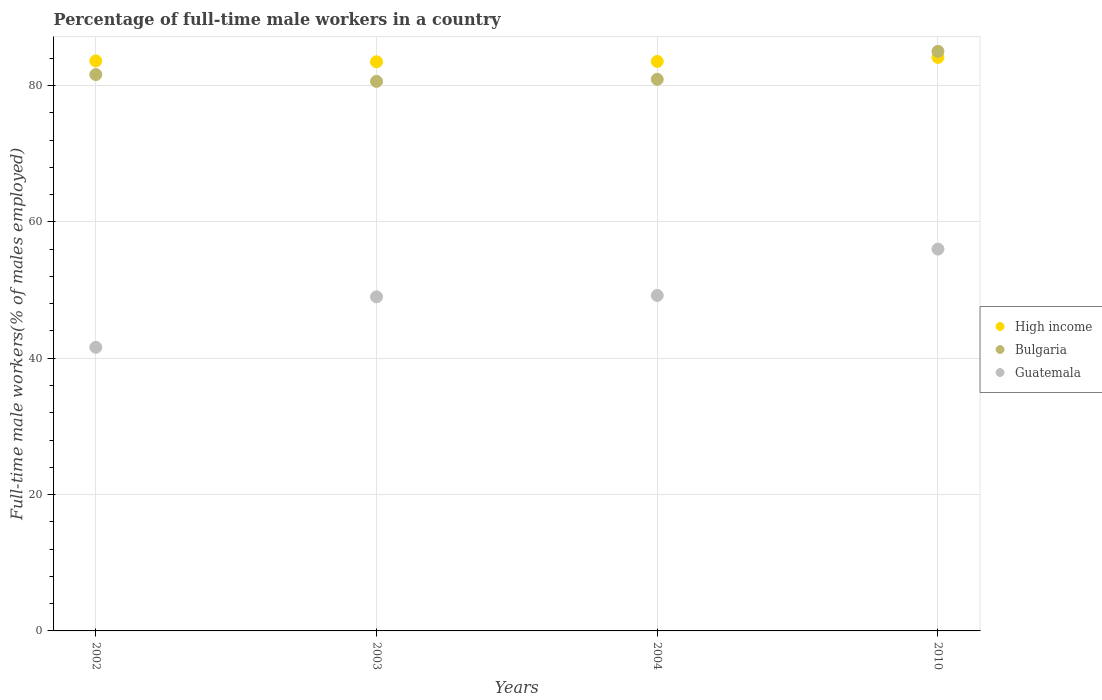Is the number of dotlines equal to the number of legend labels?
Provide a succinct answer. Yes. What is the percentage of full-time male workers in High income in 2002?
Give a very brief answer. 83.6. Across all years, what is the maximum percentage of full-time male workers in Bulgaria?
Give a very brief answer. 85. Across all years, what is the minimum percentage of full-time male workers in Guatemala?
Make the answer very short. 41.6. In which year was the percentage of full-time male workers in High income minimum?
Your answer should be very brief. 2003. What is the total percentage of full-time male workers in Guatemala in the graph?
Provide a succinct answer. 195.8. What is the difference between the percentage of full-time male workers in High income in 2002 and that in 2004?
Provide a succinct answer. 0.07. What is the difference between the percentage of full-time male workers in Bulgaria in 2003 and the percentage of full-time male workers in High income in 2010?
Make the answer very short. -3.51. What is the average percentage of full-time male workers in Bulgaria per year?
Make the answer very short. 82.02. In the year 2004, what is the difference between the percentage of full-time male workers in High income and percentage of full-time male workers in Guatemala?
Ensure brevity in your answer.  34.33. In how many years, is the percentage of full-time male workers in Guatemala greater than 68 %?
Provide a succinct answer. 0. What is the ratio of the percentage of full-time male workers in Bulgaria in 2004 to that in 2010?
Offer a terse response. 0.95. Is the percentage of full-time male workers in Guatemala in 2002 less than that in 2010?
Your response must be concise. Yes. What is the difference between the highest and the second highest percentage of full-time male workers in Guatemala?
Your response must be concise. 6.8. What is the difference between the highest and the lowest percentage of full-time male workers in High income?
Give a very brief answer. 0.64. In how many years, is the percentage of full-time male workers in Guatemala greater than the average percentage of full-time male workers in Guatemala taken over all years?
Provide a succinct answer. 3. Is the sum of the percentage of full-time male workers in High income in 2002 and 2004 greater than the maximum percentage of full-time male workers in Bulgaria across all years?
Your response must be concise. Yes. Is the percentage of full-time male workers in Bulgaria strictly greater than the percentage of full-time male workers in Guatemala over the years?
Your answer should be very brief. Yes. Is the percentage of full-time male workers in High income strictly less than the percentage of full-time male workers in Guatemala over the years?
Make the answer very short. No. How many years are there in the graph?
Make the answer very short. 4. What is the difference between two consecutive major ticks on the Y-axis?
Your answer should be very brief. 20. Are the values on the major ticks of Y-axis written in scientific E-notation?
Your response must be concise. No. Does the graph contain any zero values?
Ensure brevity in your answer.  No. Where does the legend appear in the graph?
Make the answer very short. Center right. How many legend labels are there?
Make the answer very short. 3. How are the legend labels stacked?
Offer a terse response. Vertical. What is the title of the graph?
Your response must be concise. Percentage of full-time male workers in a country. Does "Egypt, Arab Rep." appear as one of the legend labels in the graph?
Provide a succinct answer. No. What is the label or title of the X-axis?
Your answer should be compact. Years. What is the label or title of the Y-axis?
Your response must be concise. Full-time male workers(% of males employed). What is the Full-time male workers(% of males employed) of High income in 2002?
Your answer should be compact. 83.6. What is the Full-time male workers(% of males employed) of Bulgaria in 2002?
Offer a terse response. 81.6. What is the Full-time male workers(% of males employed) in Guatemala in 2002?
Your answer should be very brief. 41.6. What is the Full-time male workers(% of males employed) in High income in 2003?
Ensure brevity in your answer.  83.47. What is the Full-time male workers(% of males employed) of Bulgaria in 2003?
Provide a succinct answer. 80.6. What is the Full-time male workers(% of males employed) of Guatemala in 2003?
Offer a very short reply. 49. What is the Full-time male workers(% of males employed) of High income in 2004?
Ensure brevity in your answer.  83.53. What is the Full-time male workers(% of males employed) in Bulgaria in 2004?
Provide a succinct answer. 80.9. What is the Full-time male workers(% of males employed) in Guatemala in 2004?
Offer a very short reply. 49.2. What is the Full-time male workers(% of males employed) of High income in 2010?
Keep it short and to the point. 84.11. What is the Full-time male workers(% of males employed) in Guatemala in 2010?
Your answer should be compact. 56. Across all years, what is the maximum Full-time male workers(% of males employed) of High income?
Offer a terse response. 84.11. Across all years, what is the minimum Full-time male workers(% of males employed) of High income?
Your answer should be very brief. 83.47. Across all years, what is the minimum Full-time male workers(% of males employed) of Bulgaria?
Make the answer very short. 80.6. Across all years, what is the minimum Full-time male workers(% of males employed) in Guatemala?
Provide a succinct answer. 41.6. What is the total Full-time male workers(% of males employed) of High income in the graph?
Keep it short and to the point. 334.71. What is the total Full-time male workers(% of males employed) of Bulgaria in the graph?
Your response must be concise. 328.1. What is the total Full-time male workers(% of males employed) in Guatemala in the graph?
Keep it short and to the point. 195.8. What is the difference between the Full-time male workers(% of males employed) in High income in 2002 and that in 2003?
Keep it short and to the point. 0.13. What is the difference between the Full-time male workers(% of males employed) in Bulgaria in 2002 and that in 2003?
Provide a succinct answer. 1. What is the difference between the Full-time male workers(% of males employed) of Guatemala in 2002 and that in 2003?
Provide a succinct answer. -7.4. What is the difference between the Full-time male workers(% of males employed) of High income in 2002 and that in 2004?
Your response must be concise. 0.07. What is the difference between the Full-time male workers(% of males employed) in Bulgaria in 2002 and that in 2004?
Provide a succinct answer. 0.7. What is the difference between the Full-time male workers(% of males employed) of Guatemala in 2002 and that in 2004?
Your answer should be very brief. -7.6. What is the difference between the Full-time male workers(% of males employed) of High income in 2002 and that in 2010?
Give a very brief answer. -0.51. What is the difference between the Full-time male workers(% of males employed) of Bulgaria in 2002 and that in 2010?
Keep it short and to the point. -3.4. What is the difference between the Full-time male workers(% of males employed) of Guatemala in 2002 and that in 2010?
Your answer should be compact. -14.4. What is the difference between the Full-time male workers(% of males employed) in High income in 2003 and that in 2004?
Provide a short and direct response. -0.06. What is the difference between the Full-time male workers(% of males employed) in High income in 2003 and that in 2010?
Your response must be concise. -0.64. What is the difference between the Full-time male workers(% of males employed) in High income in 2004 and that in 2010?
Your answer should be very brief. -0.58. What is the difference between the Full-time male workers(% of males employed) in Bulgaria in 2004 and that in 2010?
Offer a very short reply. -4.1. What is the difference between the Full-time male workers(% of males employed) of Guatemala in 2004 and that in 2010?
Your answer should be very brief. -6.8. What is the difference between the Full-time male workers(% of males employed) of High income in 2002 and the Full-time male workers(% of males employed) of Bulgaria in 2003?
Give a very brief answer. 3. What is the difference between the Full-time male workers(% of males employed) of High income in 2002 and the Full-time male workers(% of males employed) of Guatemala in 2003?
Your response must be concise. 34.6. What is the difference between the Full-time male workers(% of males employed) in Bulgaria in 2002 and the Full-time male workers(% of males employed) in Guatemala in 2003?
Keep it short and to the point. 32.6. What is the difference between the Full-time male workers(% of males employed) of High income in 2002 and the Full-time male workers(% of males employed) of Bulgaria in 2004?
Keep it short and to the point. 2.7. What is the difference between the Full-time male workers(% of males employed) in High income in 2002 and the Full-time male workers(% of males employed) in Guatemala in 2004?
Your response must be concise. 34.4. What is the difference between the Full-time male workers(% of males employed) in Bulgaria in 2002 and the Full-time male workers(% of males employed) in Guatemala in 2004?
Ensure brevity in your answer.  32.4. What is the difference between the Full-time male workers(% of males employed) of High income in 2002 and the Full-time male workers(% of males employed) of Bulgaria in 2010?
Your answer should be compact. -1.4. What is the difference between the Full-time male workers(% of males employed) in High income in 2002 and the Full-time male workers(% of males employed) in Guatemala in 2010?
Ensure brevity in your answer.  27.6. What is the difference between the Full-time male workers(% of males employed) in Bulgaria in 2002 and the Full-time male workers(% of males employed) in Guatemala in 2010?
Keep it short and to the point. 25.6. What is the difference between the Full-time male workers(% of males employed) in High income in 2003 and the Full-time male workers(% of males employed) in Bulgaria in 2004?
Provide a short and direct response. 2.57. What is the difference between the Full-time male workers(% of males employed) in High income in 2003 and the Full-time male workers(% of males employed) in Guatemala in 2004?
Make the answer very short. 34.27. What is the difference between the Full-time male workers(% of males employed) of Bulgaria in 2003 and the Full-time male workers(% of males employed) of Guatemala in 2004?
Offer a terse response. 31.4. What is the difference between the Full-time male workers(% of males employed) in High income in 2003 and the Full-time male workers(% of males employed) in Bulgaria in 2010?
Your answer should be very brief. -1.53. What is the difference between the Full-time male workers(% of males employed) in High income in 2003 and the Full-time male workers(% of males employed) in Guatemala in 2010?
Your answer should be very brief. 27.47. What is the difference between the Full-time male workers(% of males employed) of Bulgaria in 2003 and the Full-time male workers(% of males employed) of Guatemala in 2010?
Offer a very short reply. 24.6. What is the difference between the Full-time male workers(% of males employed) of High income in 2004 and the Full-time male workers(% of males employed) of Bulgaria in 2010?
Give a very brief answer. -1.47. What is the difference between the Full-time male workers(% of males employed) of High income in 2004 and the Full-time male workers(% of males employed) of Guatemala in 2010?
Your answer should be compact. 27.53. What is the difference between the Full-time male workers(% of males employed) in Bulgaria in 2004 and the Full-time male workers(% of males employed) in Guatemala in 2010?
Offer a terse response. 24.9. What is the average Full-time male workers(% of males employed) of High income per year?
Offer a very short reply. 83.68. What is the average Full-time male workers(% of males employed) in Bulgaria per year?
Keep it short and to the point. 82.03. What is the average Full-time male workers(% of males employed) of Guatemala per year?
Keep it short and to the point. 48.95. In the year 2002, what is the difference between the Full-time male workers(% of males employed) of High income and Full-time male workers(% of males employed) of Bulgaria?
Provide a succinct answer. 2. In the year 2002, what is the difference between the Full-time male workers(% of males employed) in High income and Full-time male workers(% of males employed) in Guatemala?
Give a very brief answer. 42. In the year 2003, what is the difference between the Full-time male workers(% of males employed) of High income and Full-time male workers(% of males employed) of Bulgaria?
Offer a very short reply. 2.87. In the year 2003, what is the difference between the Full-time male workers(% of males employed) of High income and Full-time male workers(% of males employed) of Guatemala?
Ensure brevity in your answer.  34.47. In the year 2003, what is the difference between the Full-time male workers(% of males employed) in Bulgaria and Full-time male workers(% of males employed) in Guatemala?
Make the answer very short. 31.6. In the year 2004, what is the difference between the Full-time male workers(% of males employed) of High income and Full-time male workers(% of males employed) of Bulgaria?
Provide a succinct answer. 2.63. In the year 2004, what is the difference between the Full-time male workers(% of males employed) of High income and Full-time male workers(% of males employed) of Guatemala?
Ensure brevity in your answer.  34.33. In the year 2004, what is the difference between the Full-time male workers(% of males employed) of Bulgaria and Full-time male workers(% of males employed) of Guatemala?
Provide a succinct answer. 31.7. In the year 2010, what is the difference between the Full-time male workers(% of males employed) in High income and Full-time male workers(% of males employed) in Bulgaria?
Provide a short and direct response. -0.89. In the year 2010, what is the difference between the Full-time male workers(% of males employed) in High income and Full-time male workers(% of males employed) in Guatemala?
Offer a terse response. 28.11. What is the ratio of the Full-time male workers(% of males employed) in Bulgaria in 2002 to that in 2003?
Your answer should be compact. 1.01. What is the ratio of the Full-time male workers(% of males employed) in Guatemala in 2002 to that in 2003?
Offer a very short reply. 0.85. What is the ratio of the Full-time male workers(% of males employed) in Bulgaria in 2002 to that in 2004?
Your response must be concise. 1.01. What is the ratio of the Full-time male workers(% of males employed) in Guatemala in 2002 to that in 2004?
Provide a succinct answer. 0.85. What is the ratio of the Full-time male workers(% of males employed) in High income in 2002 to that in 2010?
Give a very brief answer. 0.99. What is the ratio of the Full-time male workers(% of males employed) of Guatemala in 2002 to that in 2010?
Your answer should be compact. 0.74. What is the ratio of the Full-time male workers(% of males employed) of High income in 2003 to that in 2004?
Keep it short and to the point. 1. What is the ratio of the Full-time male workers(% of males employed) in Bulgaria in 2003 to that in 2004?
Your answer should be compact. 1. What is the ratio of the Full-time male workers(% of males employed) in High income in 2003 to that in 2010?
Your response must be concise. 0.99. What is the ratio of the Full-time male workers(% of males employed) of Bulgaria in 2003 to that in 2010?
Make the answer very short. 0.95. What is the ratio of the Full-time male workers(% of males employed) in Guatemala in 2003 to that in 2010?
Your answer should be very brief. 0.88. What is the ratio of the Full-time male workers(% of males employed) in Bulgaria in 2004 to that in 2010?
Make the answer very short. 0.95. What is the ratio of the Full-time male workers(% of males employed) in Guatemala in 2004 to that in 2010?
Your response must be concise. 0.88. What is the difference between the highest and the second highest Full-time male workers(% of males employed) in High income?
Offer a terse response. 0.51. What is the difference between the highest and the second highest Full-time male workers(% of males employed) of Bulgaria?
Your answer should be very brief. 3.4. What is the difference between the highest and the lowest Full-time male workers(% of males employed) of High income?
Your answer should be compact. 0.64. What is the difference between the highest and the lowest Full-time male workers(% of males employed) of Bulgaria?
Keep it short and to the point. 4.4. What is the difference between the highest and the lowest Full-time male workers(% of males employed) of Guatemala?
Offer a terse response. 14.4. 